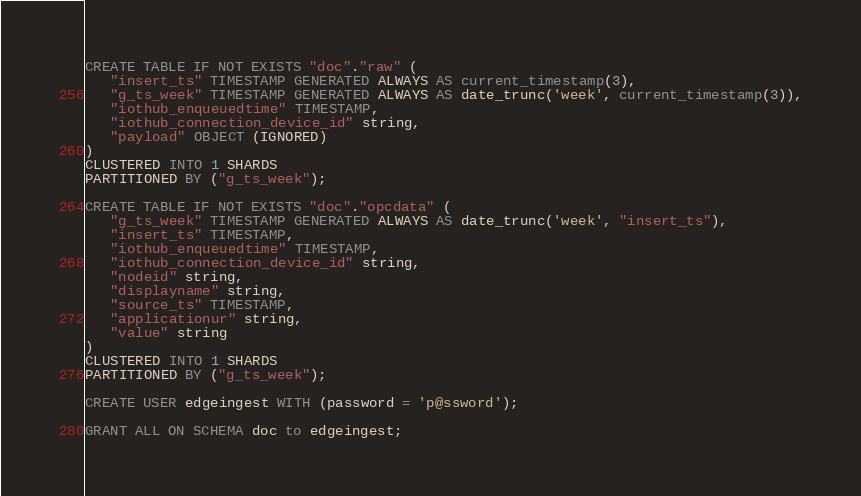<code> <loc_0><loc_0><loc_500><loc_500><_SQL_>CREATE TABLE IF NOT EXISTS "doc"."raw" (
   "insert_ts" TIMESTAMP GENERATED ALWAYS AS current_timestamp(3),
   "g_ts_week" TIMESTAMP GENERATED ALWAYS AS date_trunc('week', current_timestamp(3)),
   "iothub_enqueuedtime" TIMESTAMP,
   "iothub_connection_device_id" string,
   "payload" OBJECT (IGNORED)
)
CLUSTERED INTO 1 SHARDS
PARTITIONED BY ("g_ts_week");

CREATE TABLE IF NOT EXISTS "doc"."opcdata" (
   "g_ts_week" TIMESTAMP GENERATED ALWAYS AS date_trunc('week', "insert_ts"),
   "insert_ts" TIMESTAMP,
   "iothub_enqueuedtime" TIMESTAMP,
   "iothub_connection_device_id" string,
   "nodeid" string,
   "displayname" string,
   "source_ts" TIMESTAMP,
   "applicationur" string,
   "value" string
)
CLUSTERED INTO 1 SHARDS
PARTITIONED BY ("g_ts_week");

CREATE USER edgeingest WITH (password = 'p@ssword');

GRANT ALL ON SCHEMA doc to edgeingest;
</code> 